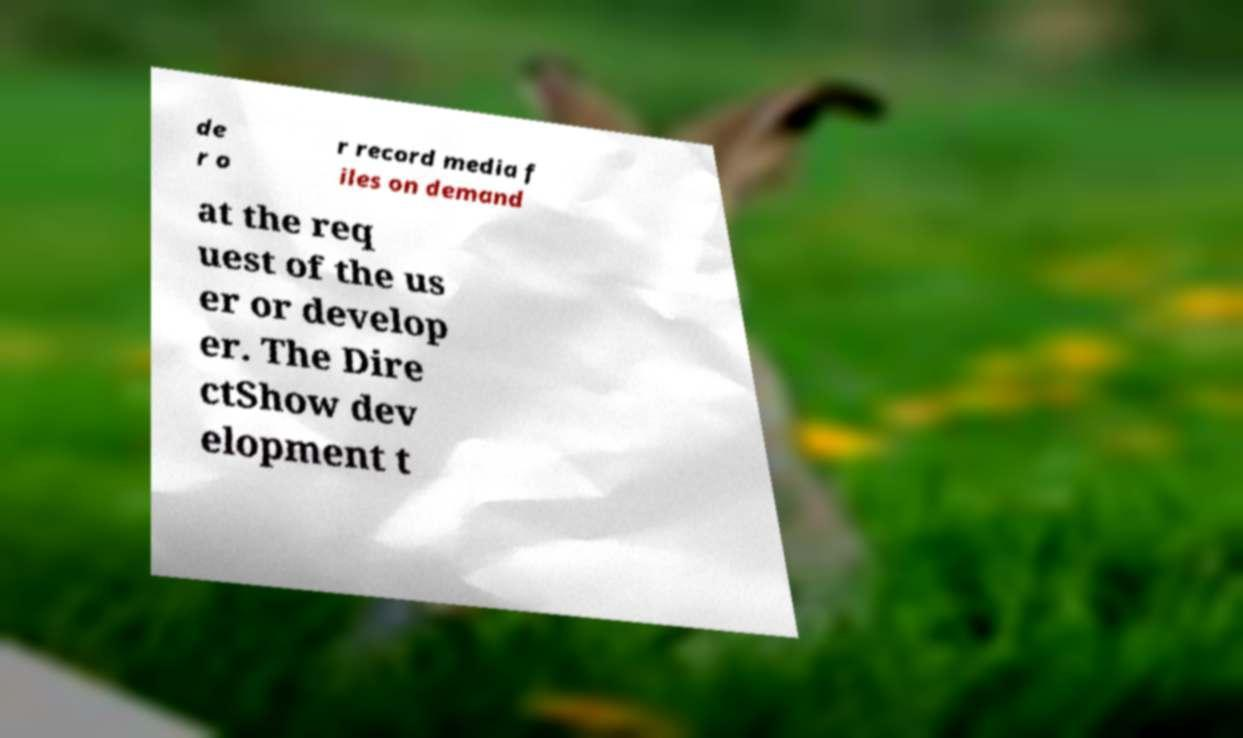Please identify and transcribe the text found in this image. de r o r record media f iles on demand at the req uest of the us er or develop er. The Dire ctShow dev elopment t 